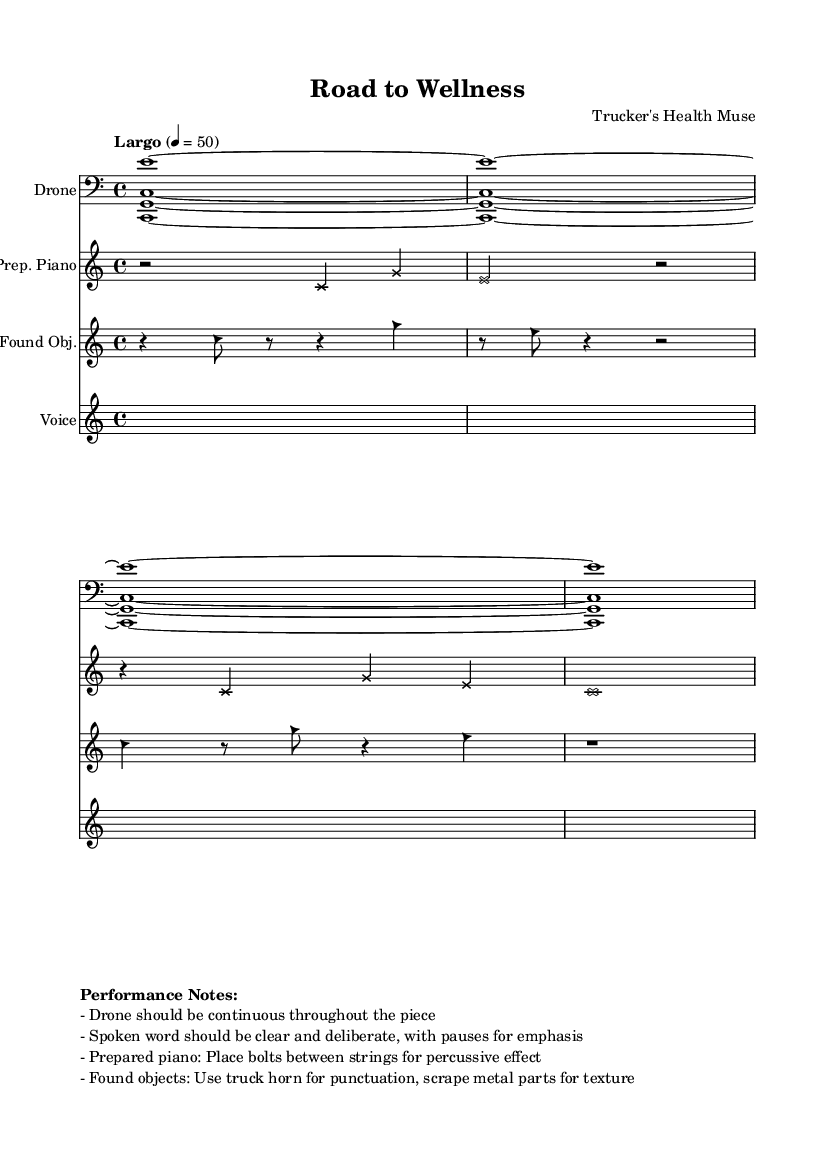What is the time signature of this music? The time signature appears at the beginning of the score, specified as 4/4. This indicates that there are four beats per measure and the quarter note receives one beat.
Answer: 4/4 What is the tempo of this piece? The tempo marking indicates "Largo," along with a specific beats per minute, which is set to 50. This suggests a slow tempo for the performance.
Answer: Largo, 50 How many staves are present in this score? The score consists of four distinct staves: Drone, Prepared Piano, Found Objects, and Voice. Each one represents a different layer of sound.
Answer: Four What type of instrument is used for the Drone? The description in the score indicates that the Drone is performed with a bass clef, which typically suggests the use of a lower-pitched instrument like a synthesizer or cello.
Answer: Bass How does the prepared piano contribute to the piece? The prepared piano is modified by placing bolts between the strings, which alters the sound quality and adds a unique percussive effect, enhancing the experimental nature of the piece.
Answer: Percussive effect What instructions are given for the spoken voice? The performance notes specify that the spoken word should be clear and deliberate, with intentional pauses for emphasis, ensuring that the wellness tips are communicated effectively.
Answer: Clear and deliberate 